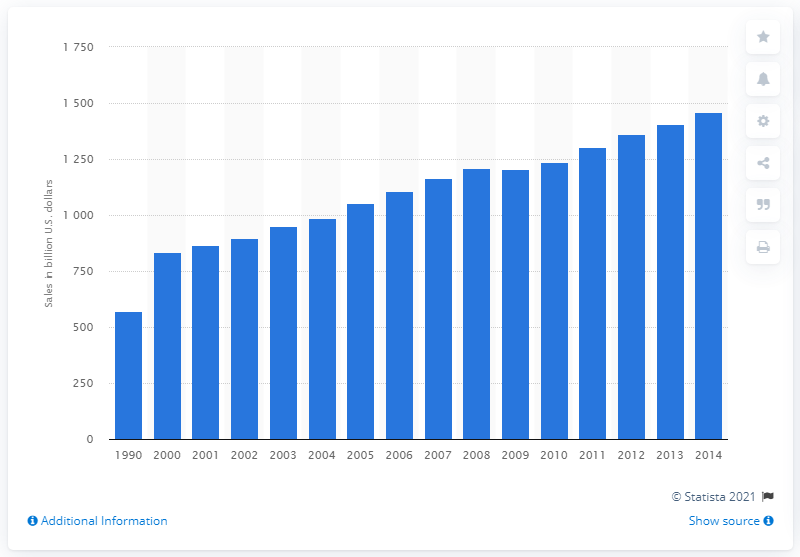Give some essential details in this illustration. The total amount of food sales in the United States from 1990 to 2014 was 1407.13 billion dollars. 